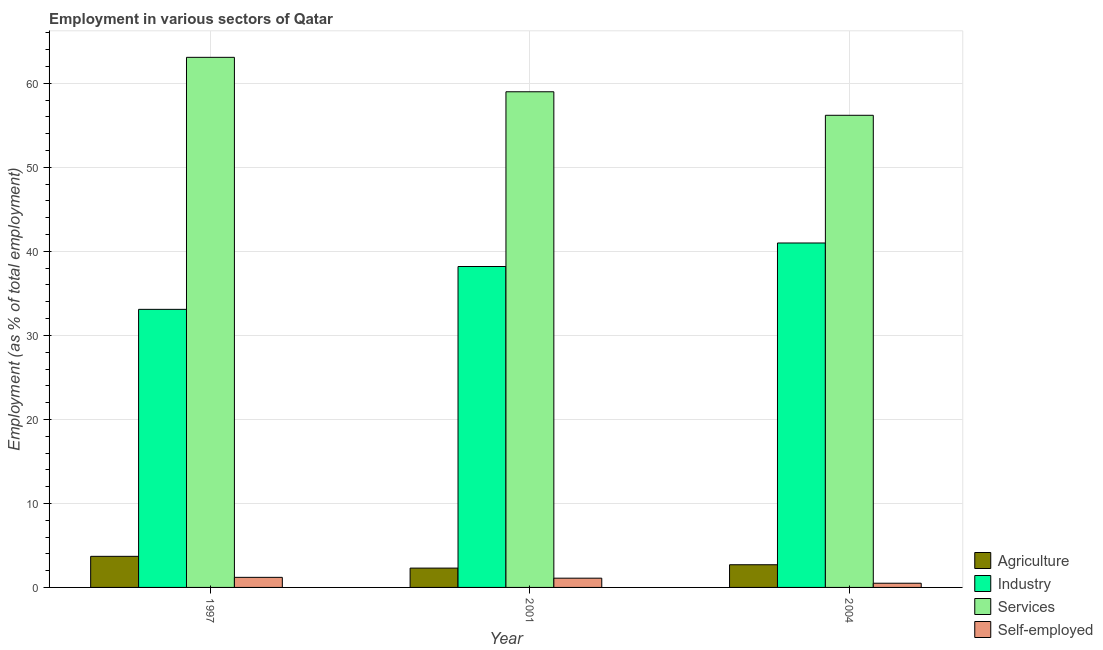How many different coloured bars are there?
Ensure brevity in your answer.  4. How many groups of bars are there?
Offer a terse response. 3. Are the number of bars on each tick of the X-axis equal?
Keep it short and to the point. Yes. How many bars are there on the 2nd tick from the right?
Give a very brief answer. 4. What is the label of the 2nd group of bars from the left?
Keep it short and to the point. 2001. In how many cases, is the number of bars for a given year not equal to the number of legend labels?
Give a very brief answer. 0. What is the percentage of workers in industry in 2001?
Your response must be concise. 38.2. Across all years, what is the maximum percentage of self employed workers?
Keep it short and to the point. 1.2. Across all years, what is the minimum percentage of workers in industry?
Your answer should be compact. 33.1. What is the total percentage of workers in industry in the graph?
Your response must be concise. 112.3. What is the difference between the percentage of workers in agriculture in 1997 and that in 2004?
Give a very brief answer. 1. What is the difference between the percentage of workers in agriculture in 1997 and the percentage of workers in industry in 2001?
Give a very brief answer. 1.4. What is the average percentage of workers in industry per year?
Ensure brevity in your answer.  37.43. In the year 1997, what is the difference between the percentage of self employed workers and percentage of workers in services?
Offer a terse response. 0. In how many years, is the percentage of self employed workers greater than 46 %?
Give a very brief answer. 0. What is the ratio of the percentage of workers in agriculture in 1997 to that in 2001?
Keep it short and to the point. 1.61. Is the percentage of workers in industry in 1997 less than that in 2001?
Your answer should be very brief. Yes. Is the difference between the percentage of workers in industry in 1997 and 2004 greater than the difference between the percentage of self employed workers in 1997 and 2004?
Your answer should be very brief. No. What is the difference between the highest and the second highest percentage of workers in services?
Offer a very short reply. 4.1. What is the difference between the highest and the lowest percentage of workers in services?
Your answer should be very brief. 6.9. Is it the case that in every year, the sum of the percentage of workers in industry and percentage of self employed workers is greater than the sum of percentage of workers in services and percentage of workers in agriculture?
Give a very brief answer. No. What does the 4th bar from the left in 2004 represents?
Provide a succinct answer. Self-employed. What does the 4th bar from the right in 1997 represents?
Your answer should be compact. Agriculture. Is it the case that in every year, the sum of the percentage of workers in agriculture and percentage of workers in industry is greater than the percentage of workers in services?
Provide a short and direct response. No. How many bars are there?
Your answer should be compact. 12. How many years are there in the graph?
Provide a succinct answer. 3. Are the values on the major ticks of Y-axis written in scientific E-notation?
Your answer should be compact. No. How are the legend labels stacked?
Keep it short and to the point. Vertical. What is the title of the graph?
Your answer should be compact. Employment in various sectors of Qatar. Does "Financial sector" appear as one of the legend labels in the graph?
Your answer should be very brief. No. What is the label or title of the X-axis?
Your response must be concise. Year. What is the label or title of the Y-axis?
Provide a succinct answer. Employment (as % of total employment). What is the Employment (as % of total employment) of Agriculture in 1997?
Give a very brief answer. 3.7. What is the Employment (as % of total employment) of Industry in 1997?
Your answer should be compact. 33.1. What is the Employment (as % of total employment) in Services in 1997?
Ensure brevity in your answer.  63.1. What is the Employment (as % of total employment) in Self-employed in 1997?
Make the answer very short. 1.2. What is the Employment (as % of total employment) of Agriculture in 2001?
Give a very brief answer. 2.3. What is the Employment (as % of total employment) in Industry in 2001?
Provide a succinct answer. 38.2. What is the Employment (as % of total employment) of Self-employed in 2001?
Your response must be concise. 1.1. What is the Employment (as % of total employment) in Agriculture in 2004?
Make the answer very short. 2.7. What is the Employment (as % of total employment) of Industry in 2004?
Ensure brevity in your answer.  41. What is the Employment (as % of total employment) of Services in 2004?
Your answer should be compact. 56.2. What is the Employment (as % of total employment) of Self-employed in 2004?
Provide a short and direct response. 0.5. Across all years, what is the maximum Employment (as % of total employment) of Agriculture?
Provide a succinct answer. 3.7. Across all years, what is the maximum Employment (as % of total employment) in Services?
Provide a succinct answer. 63.1. Across all years, what is the maximum Employment (as % of total employment) in Self-employed?
Ensure brevity in your answer.  1.2. Across all years, what is the minimum Employment (as % of total employment) of Agriculture?
Your answer should be compact. 2.3. Across all years, what is the minimum Employment (as % of total employment) in Industry?
Your answer should be very brief. 33.1. Across all years, what is the minimum Employment (as % of total employment) of Services?
Your answer should be very brief. 56.2. Across all years, what is the minimum Employment (as % of total employment) in Self-employed?
Keep it short and to the point. 0.5. What is the total Employment (as % of total employment) of Agriculture in the graph?
Ensure brevity in your answer.  8.7. What is the total Employment (as % of total employment) in Industry in the graph?
Provide a succinct answer. 112.3. What is the total Employment (as % of total employment) in Services in the graph?
Your response must be concise. 178.3. What is the total Employment (as % of total employment) of Self-employed in the graph?
Offer a terse response. 2.8. What is the difference between the Employment (as % of total employment) in Industry in 1997 and that in 2001?
Ensure brevity in your answer.  -5.1. What is the difference between the Employment (as % of total employment) in Agriculture in 1997 and that in 2004?
Offer a very short reply. 1. What is the difference between the Employment (as % of total employment) in Agriculture in 2001 and that in 2004?
Give a very brief answer. -0.4. What is the difference between the Employment (as % of total employment) in Industry in 2001 and that in 2004?
Make the answer very short. -2.8. What is the difference between the Employment (as % of total employment) of Self-employed in 2001 and that in 2004?
Keep it short and to the point. 0.6. What is the difference between the Employment (as % of total employment) of Agriculture in 1997 and the Employment (as % of total employment) of Industry in 2001?
Provide a succinct answer. -34.5. What is the difference between the Employment (as % of total employment) in Agriculture in 1997 and the Employment (as % of total employment) in Services in 2001?
Your answer should be very brief. -55.3. What is the difference between the Employment (as % of total employment) in Industry in 1997 and the Employment (as % of total employment) in Services in 2001?
Your answer should be compact. -25.9. What is the difference between the Employment (as % of total employment) in Industry in 1997 and the Employment (as % of total employment) in Self-employed in 2001?
Offer a terse response. 32. What is the difference between the Employment (as % of total employment) of Services in 1997 and the Employment (as % of total employment) of Self-employed in 2001?
Make the answer very short. 62. What is the difference between the Employment (as % of total employment) in Agriculture in 1997 and the Employment (as % of total employment) in Industry in 2004?
Your response must be concise. -37.3. What is the difference between the Employment (as % of total employment) in Agriculture in 1997 and the Employment (as % of total employment) in Services in 2004?
Your answer should be very brief. -52.5. What is the difference between the Employment (as % of total employment) of Industry in 1997 and the Employment (as % of total employment) of Services in 2004?
Your answer should be very brief. -23.1. What is the difference between the Employment (as % of total employment) in Industry in 1997 and the Employment (as % of total employment) in Self-employed in 2004?
Your answer should be compact. 32.6. What is the difference between the Employment (as % of total employment) of Services in 1997 and the Employment (as % of total employment) of Self-employed in 2004?
Keep it short and to the point. 62.6. What is the difference between the Employment (as % of total employment) in Agriculture in 2001 and the Employment (as % of total employment) in Industry in 2004?
Provide a succinct answer. -38.7. What is the difference between the Employment (as % of total employment) in Agriculture in 2001 and the Employment (as % of total employment) in Services in 2004?
Your response must be concise. -53.9. What is the difference between the Employment (as % of total employment) in Industry in 2001 and the Employment (as % of total employment) in Services in 2004?
Offer a terse response. -18. What is the difference between the Employment (as % of total employment) in Industry in 2001 and the Employment (as % of total employment) in Self-employed in 2004?
Provide a short and direct response. 37.7. What is the difference between the Employment (as % of total employment) of Services in 2001 and the Employment (as % of total employment) of Self-employed in 2004?
Make the answer very short. 58.5. What is the average Employment (as % of total employment) of Agriculture per year?
Ensure brevity in your answer.  2.9. What is the average Employment (as % of total employment) of Industry per year?
Your response must be concise. 37.43. What is the average Employment (as % of total employment) of Services per year?
Your answer should be compact. 59.43. What is the average Employment (as % of total employment) in Self-employed per year?
Offer a terse response. 0.93. In the year 1997, what is the difference between the Employment (as % of total employment) of Agriculture and Employment (as % of total employment) of Industry?
Give a very brief answer. -29.4. In the year 1997, what is the difference between the Employment (as % of total employment) of Agriculture and Employment (as % of total employment) of Services?
Your response must be concise. -59.4. In the year 1997, what is the difference between the Employment (as % of total employment) in Agriculture and Employment (as % of total employment) in Self-employed?
Provide a succinct answer. 2.5. In the year 1997, what is the difference between the Employment (as % of total employment) of Industry and Employment (as % of total employment) of Self-employed?
Offer a terse response. 31.9. In the year 1997, what is the difference between the Employment (as % of total employment) of Services and Employment (as % of total employment) of Self-employed?
Keep it short and to the point. 61.9. In the year 2001, what is the difference between the Employment (as % of total employment) of Agriculture and Employment (as % of total employment) of Industry?
Your answer should be very brief. -35.9. In the year 2001, what is the difference between the Employment (as % of total employment) in Agriculture and Employment (as % of total employment) in Services?
Provide a short and direct response. -56.7. In the year 2001, what is the difference between the Employment (as % of total employment) of Agriculture and Employment (as % of total employment) of Self-employed?
Provide a short and direct response. 1.2. In the year 2001, what is the difference between the Employment (as % of total employment) in Industry and Employment (as % of total employment) in Services?
Make the answer very short. -20.8. In the year 2001, what is the difference between the Employment (as % of total employment) in Industry and Employment (as % of total employment) in Self-employed?
Offer a very short reply. 37.1. In the year 2001, what is the difference between the Employment (as % of total employment) of Services and Employment (as % of total employment) of Self-employed?
Give a very brief answer. 57.9. In the year 2004, what is the difference between the Employment (as % of total employment) in Agriculture and Employment (as % of total employment) in Industry?
Your answer should be compact. -38.3. In the year 2004, what is the difference between the Employment (as % of total employment) in Agriculture and Employment (as % of total employment) in Services?
Offer a very short reply. -53.5. In the year 2004, what is the difference between the Employment (as % of total employment) of Agriculture and Employment (as % of total employment) of Self-employed?
Provide a short and direct response. 2.2. In the year 2004, what is the difference between the Employment (as % of total employment) of Industry and Employment (as % of total employment) of Services?
Give a very brief answer. -15.2. In the year 2004, what is the difference between the Employment (as % of total employment) in Industry and Employment (as % of total employment) in Self-employed?
Your answer should be very brief. 40.5. In the year 2004, what is the difference between the Employment (as % of total employment) in Services and Employment (as % of total employment) in Self-employed?
Your response must be concise. 55.7. What is the ratio of the Employment (as % of total employment) in Agriculture in 1997 to that in 2001?
Keep it short and to the point. 1.61. What is the ratio of the Employment (as % of total employment) of Industry in 1997 to that in 2001?
Your response must be concise. 0.87. What is the ratio of the Employment (as % of total employment) of Services in 1997 to that in 2001?
Keep it short and to the point. 1.07. What is the ratio of the Employment (as % of total employment) in Agriculture in 1997 to that in 2004?
Provide a succinct answer. 1.37. What is the ratio of the Employment (as % of total employment) of Industry in 1997 to that in 2004?
Offer a terse response. 0.81. What is the ratio of the Employment (as % of total employment) of Services in 1997 to that in 2004?
Your answer should be very brief. 1.12. What is the ratio of the Employment (as % of total employment) in Agriculture in 2001 to that in 2004?
Offer a terse response. 0.85. What is the ratio of the Employment (as % of total employment) in Industry in 2001 to that in 2004?
Your answer should be compact. 0.93. What is the ratio of the Employment (as % of total employment) of Services in 2001 to that in 2004?
Offer a terse response. 1.05. What is the difference between the highest and the second highest Employment (as % of total employment) in Agriculture?
Your response must be concise. 1. What is the difference between the highest and the lowest Employment (as % of total employment) of Industry?
Provide a short and direct response. 7.9. What is the difference between the highest and the lowest Employment (as % of total employment) in Services?
Make the answer very short. 6.9. What is the difference between the highest and the lowest Employment (as % of total employment) of Self-employed?
Your response must be concise. 0.7. 